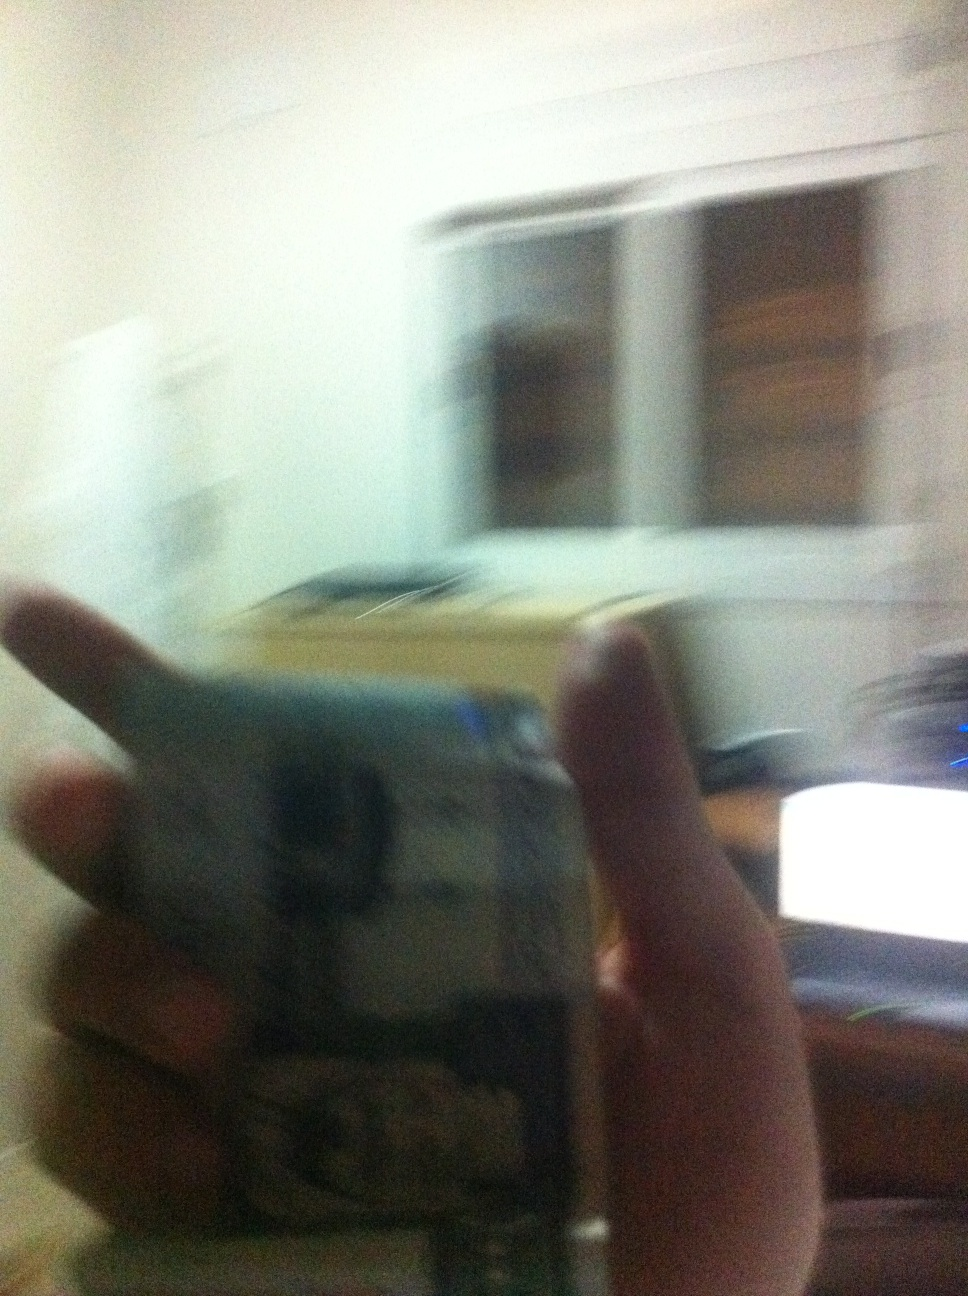How much is this? The image is blurry, making it difficult to accurately determine the amount shown in the photo. For a more precise answer, a clearer image would be needed. 